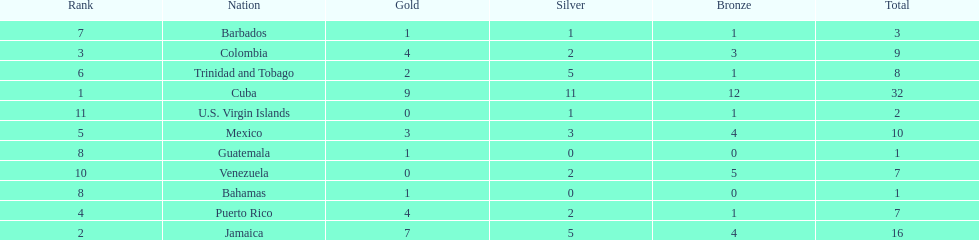Parse the full table. {'header': ['Rank', 'Nation', 'Gold', 'Silver', 'Bronze', 'Total'], 'rows': [['7', 'Barbados', '1', '1', '1', '3'], ['3', 'Colombia', '4', '2', '3', '9'], ['6', 'Trinidad and Tobago', '2', '5', '1', '8'], ['1', 'Cuba', '9', '11', '12', '32'], ['11', 'U.S. Virgin Islands', '0', '1', '1', '2'], ['5', 'Mexico', '3', '3', '4', '10'], ['8', 'Guatemala', '1', '0', '0', '1'], ['10', 'Venezuela', '0', '2', '5', '7'], ['8', 'Bahamas', '1', '0', '0', '1'], ['4', 'Puerto Rico', '4', '2', '1', '7'], ['2', 'Jamaica', '7', '5', '4', '16']]} Only team to have more than 30 medals Cuba. 